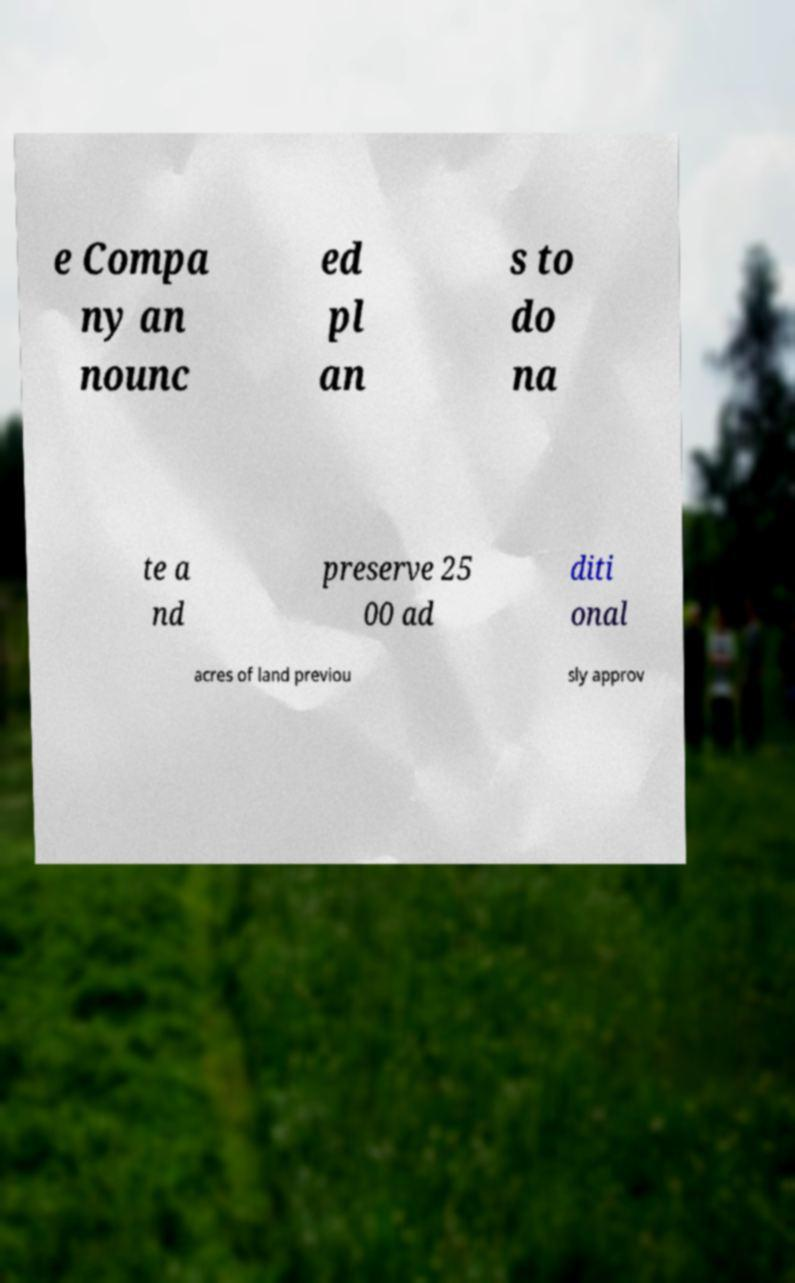I need the written content from this picture converted into text. Can you do that? e Compa ny an nounc ed pl an s to do na te a nd preserve 25 00 ad diti onal acres of land previou sly approv 